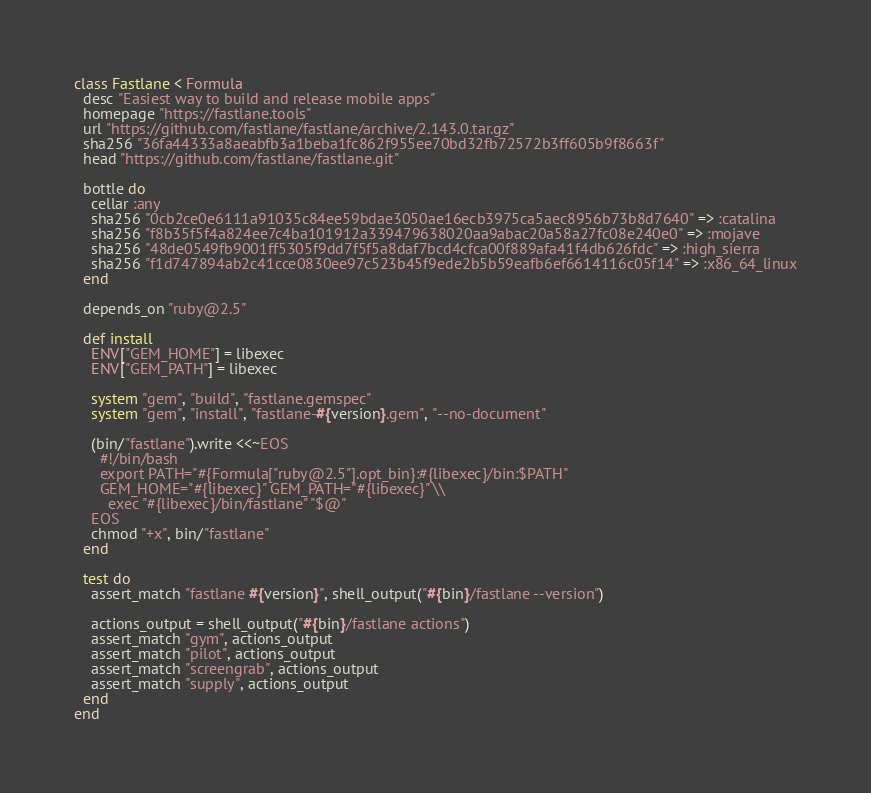<code> <loc_0><loc_0><loc_500><loc_500><_Ruby_>class Fastlane < Formula
  desc "Easiest way to build and release mobile apps"
  homepage "https://fastlane.tools"
  url "https://github.com/fastlane/fastlane/archive/2.143.0.tar.gz"
  sha256 "36fa44333a8aeabfb3a1beba1fc862f955ee70bd32fb72572b3ff605b9f8663f"
  head "https://github.com/fastlane/fastlane.git"

  bottle do
    cellar :any
    sha256 "0cb2ce0e6111a91035c84ee59bdae3050ae16ecb3975ca5aec8956b73b8d7640" => :catalina
    sha256 "f8b35f5f4a824ee7c4ba101912a339479638020aa9abac20a58a27fc08e240e0" => :mojave
    sha256 "48de0549fb9001ff5305f9dd7f5f5a8daf7bcd4cfca00f889afa41f4db626fdc" => :high_sierra
    sha256 "f1d747894ab2c41cce0830ee97c523b45f9ede2b5b59eafb6ef6614116c05f14" => :x86_64_linux
  end

  depends_on "ruby@2.5"

  def install
    ENV["GEM_HOME"] = libexec
    ENV["GEM_PATH"] = libexec

    system "gem", "build", "fastlane.gemspec"
    system "gem", "install", "fastlane-#{version}.gem", "--no-document"

    (bin/"fastlane").write <<~EOS
      #!/bin/bash
      export PATH="#{Formula["ruby@2.5"].opt_bin}:#{libexec}/bin:$PATH"
      GEM_HOME="#{libexec}" GEM_PATH="#{libexec}" \\
        exec "#{libexec}/bin/fastlane" "$@"
    EOS
    chmod "+x", bin/"fastlane"
  end

  test do
    assert_match "fastlane #{version}", shell_output("#{bin}/fastlane --version")

    actions_output = shell_output("#{bin}/fastlane actions")
    assert_match "gym", actions_output
    assert_match "pilot", actions_output
    assert_match "screengrab", actions_output
    assert_match "supply", actions_output
  end
end
</code> 